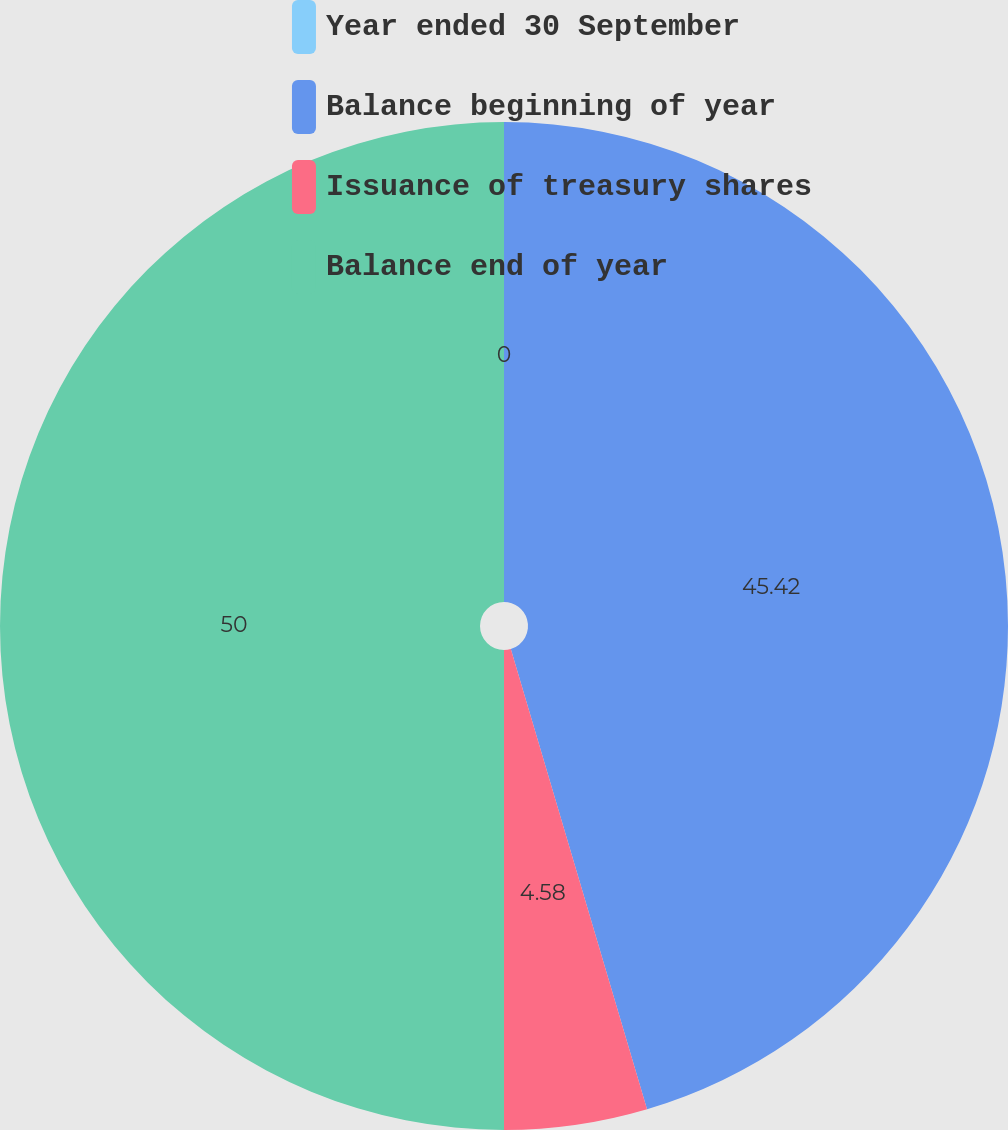Convert chart to OTSL. <chart><loc_0><loc_0><loc_500><loc_500><pie_chart><fcel>Year ended 30 September<fcel>Balance beginning of year<fcel>Issuance of treasury shares<fcel>Balance end of year<nl><fcel>0.0%<fcel>45.42%<fcel>4.58%<fcel>50.0%<nl></chart> 